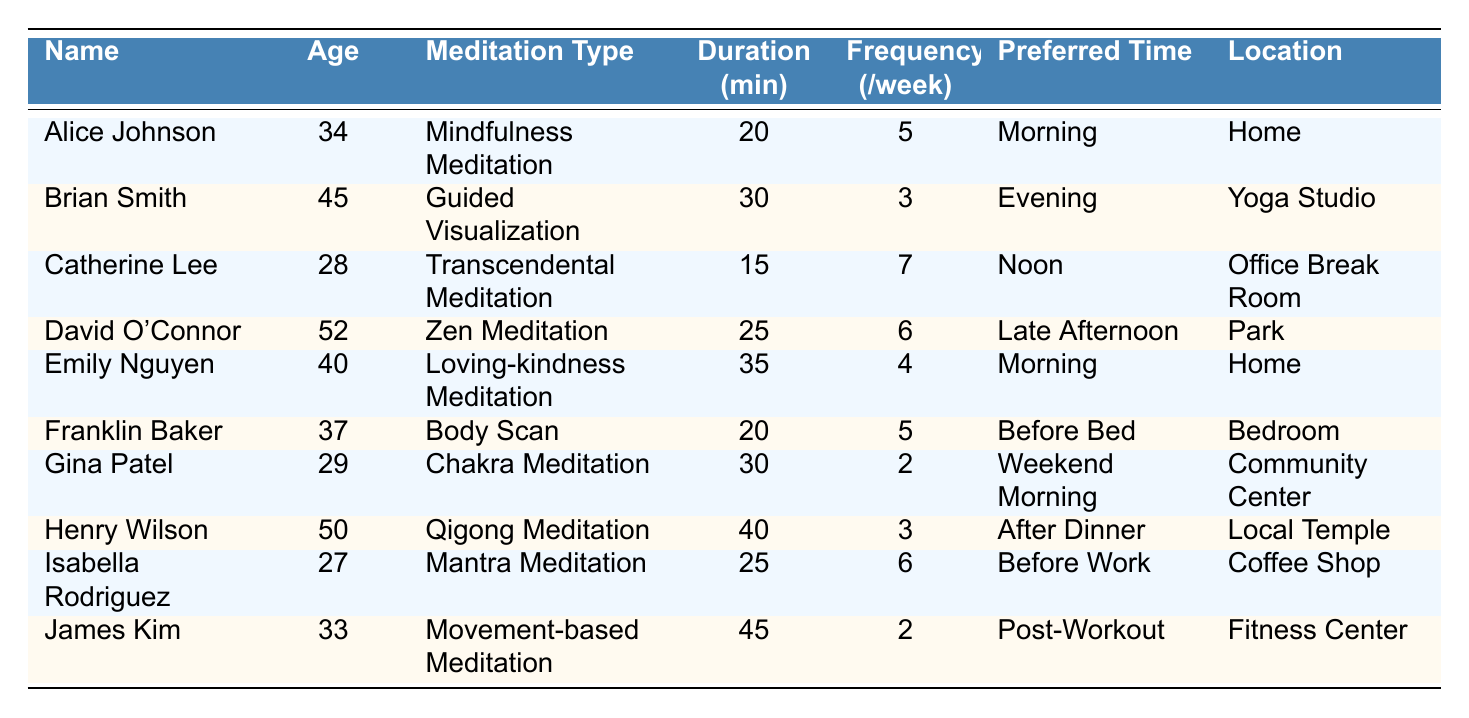What type of meditation does David O'Connor practice? David O'Connor's row in the table indicates that he practices Zen Meditation.
Answer: Zen Meditation How many minutes does Emily Nguyen meditate for each session? The table shows that Emily Nguyen has a meditation duration of 35 minutes.
Answer: 35 Which participant has the highest weekly frequency of meditation? Catherine Lee meditates 7 times a week, which is the highest frequency compared to the others listed.
Answer: Catherine Lee What is the average duration of meditation practices among all participants? To find the average duration, add the durations (20 + 30 + 15 + 25 + 35 + 20 + 30 + 40 + 25 + 45 = 315) and divide by the number of participants (10), resulting in an average of 31.5 minutes.
Answer: 31.5 Is there a participant who prefers to meditate in the evening? Looking at the table, Brian Smith has chosen the evening as his preferred time for meditation, confirming that there is at least one participant who meditates in the evening.
Answer: Yes What meditation type is practiced by the youngest participant? The youngest participant is Isabella Rodriguez, who is 27 years old, and she practices Mantra Meditation.
Answer: Mantra Meditation What is the total weekly frequency of meditation for participants who prefer to meditate in the morning? The participants who prefer morning meditation are Alice Johnson (5) and Emily Nguyen (4). The total frequency is calculated as 5 + 4 = 9.
Answer: 9 How many participants meditate for more than 30 minutes? The participants with durations greater than 30 minutes are Brian Smith (30), Emily Nguyen (35), Henry Wilson (40), and James Kim (45), totaling 4 participants.
Answer: 4 What location is preferred by David O'Connor for his meditation practice? The table states that David O'Connor prefers to meditate in the Park.
Answer: Park 